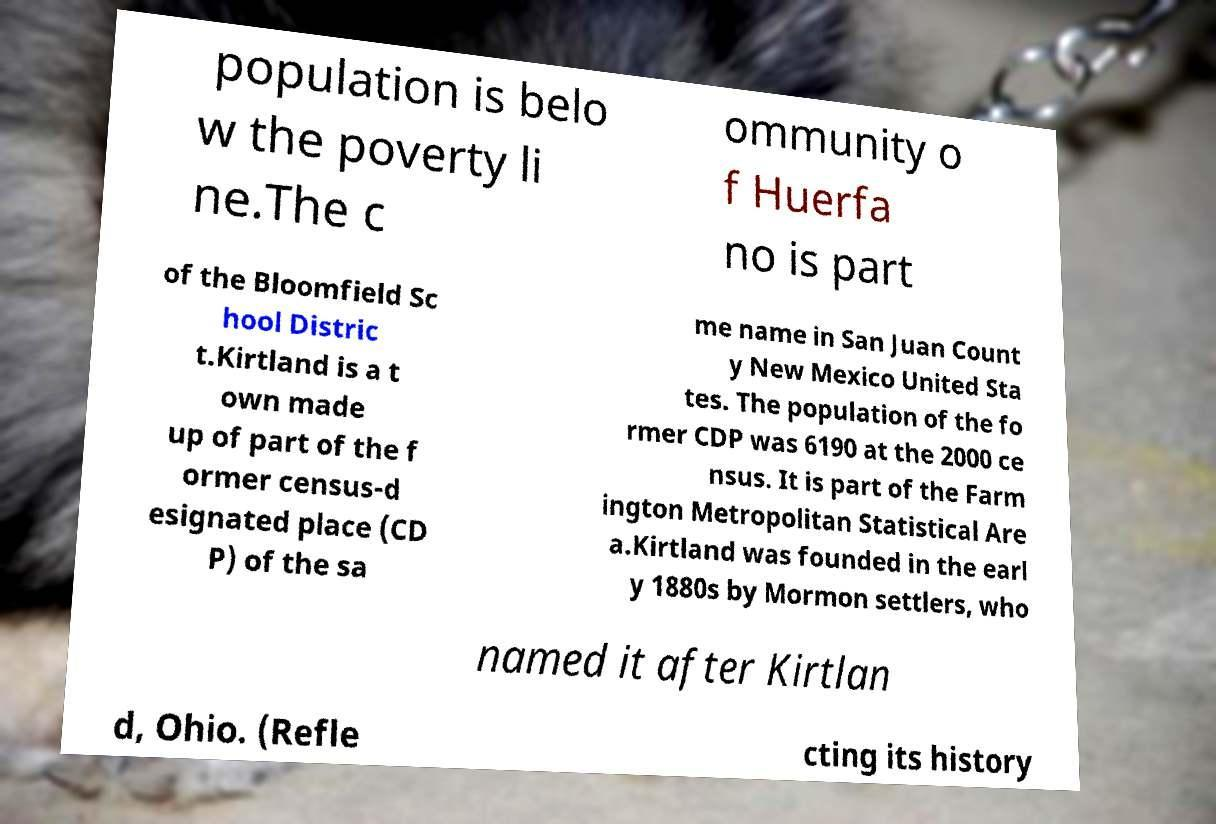For documentation purposes, I need the text within this image transcribed. Could you provide that? population is belo w the poverty li ne.The c ommunity o f Huerfa no is part of the Bloomfield Sc hool Distric t.Kirtland is a t own made up of part of the f ormer census-d esignated place (CD P) of the sa me name in San Juan Count y New Mexico United Sta tes. The population of the fo rmer CDP was 6190 at the 2000 ce nsus. It is part of the Farm ington Metropolitan Statistical Are a.Kirtland was founded in the earl y 1880s by Mormon settlers, who named it after Kirtlan d, Ohio. (Refle cting its history 